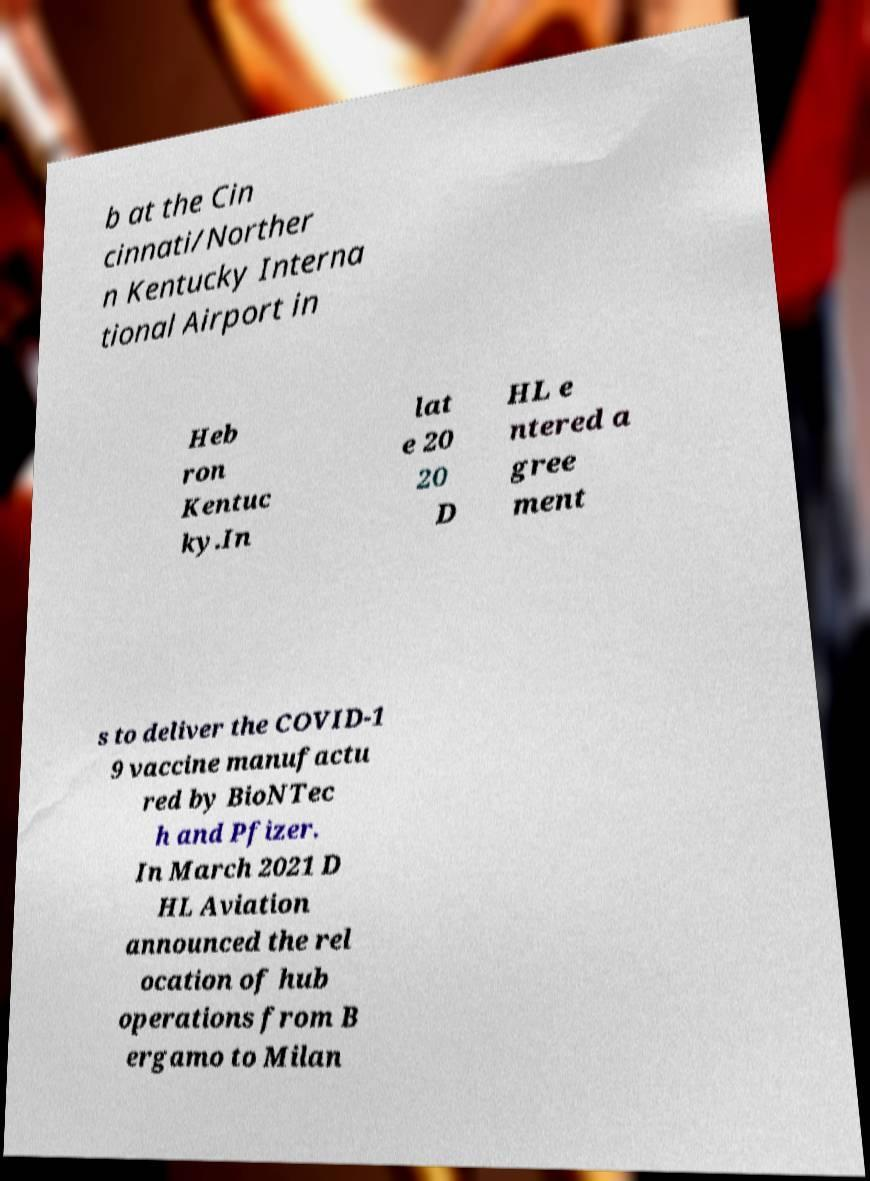For documentation purposes, I need the text within this image transcribed. Could you provide that? b at the Cin cinnati/Norther n Kentucky Interna tional Airport in Heb ron Kentuc ky.In lat e 20 20 D HL e ntered a gree ment s to deliver the COVID-1 9 vaccine manufactu red by BioNTec h and Pfizer. In March 2021 D HL Aviation announced the rel ocation of hub operations from B ergamo to Milan 